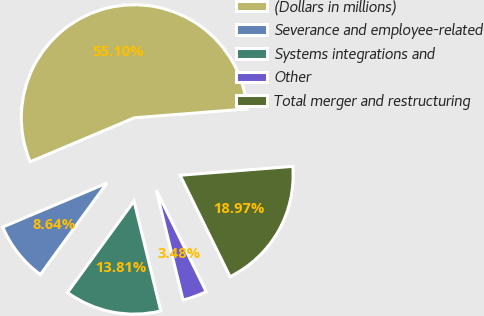<chart> <loc_0><loc_0><loc_500><loc_500><pie_chart><fcel>(Dollars in millions)<fcel>Severance and employee-related<fcel>Systems integrations and<fcel>Other<fcel>Total merger and restructuring<nl><fcel>55.1%<fcel>8.64%<fcel>13.81%<fcel>3.48%<fcel>18.97%<nl></chart> 